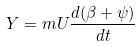Convert formula to latex. <formula><loc_0><loc_0><loc_500><loc_500>Y = m U \frac { d ( \beta + \psi ) } { d t }</formula> 